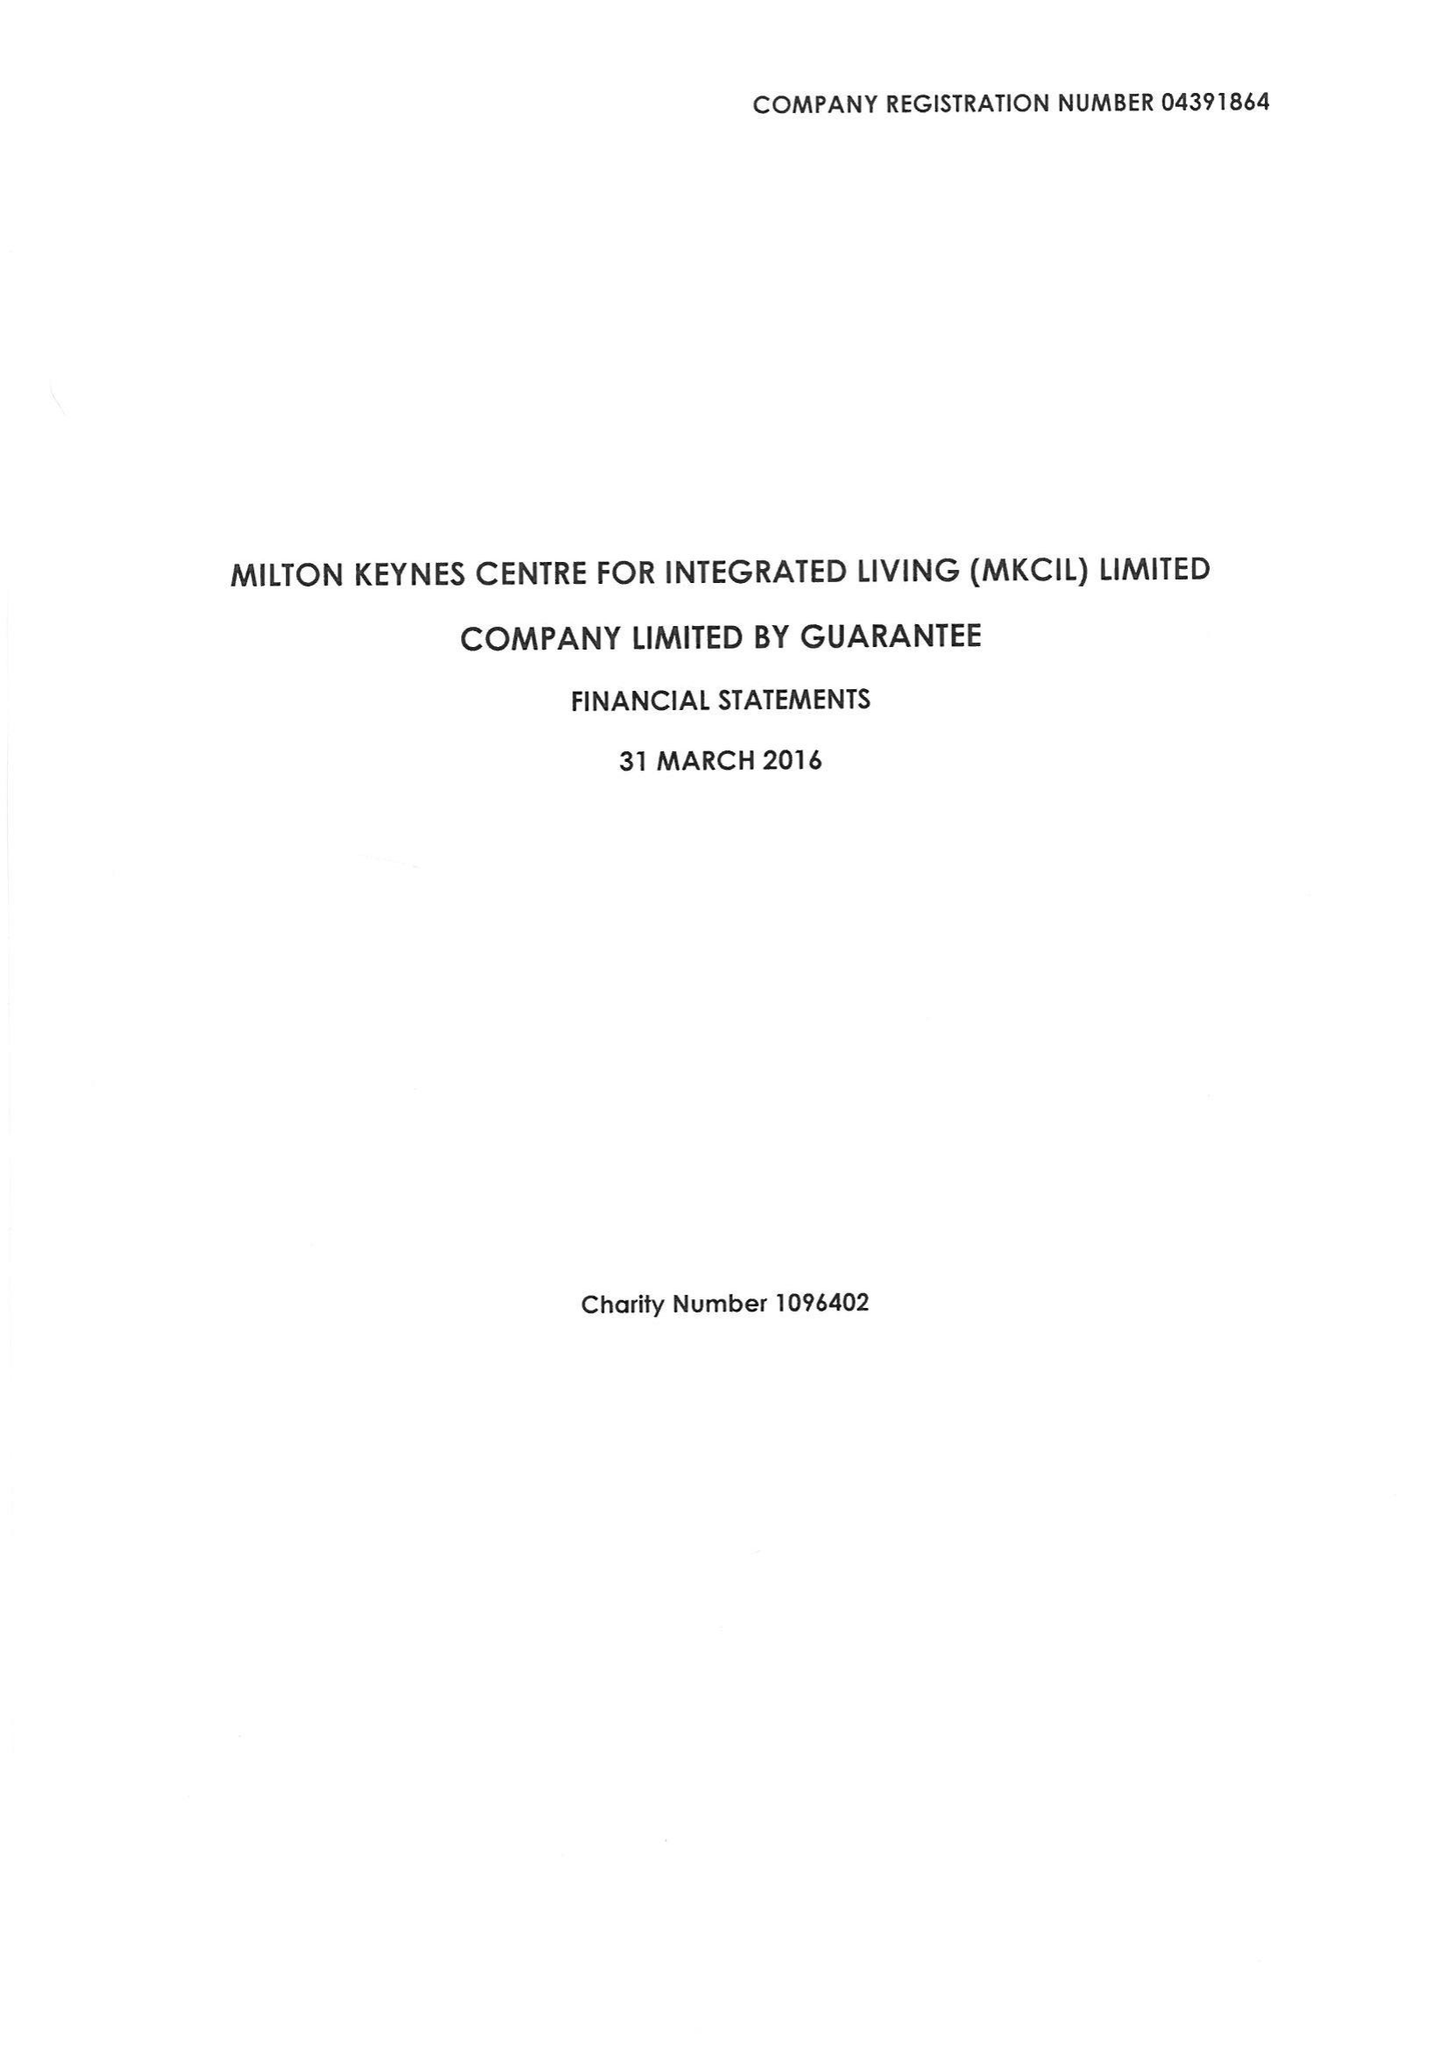What is the value for the income_annually_in_british_pounds?
Answer the question using a single word or phrase. 416529.00 